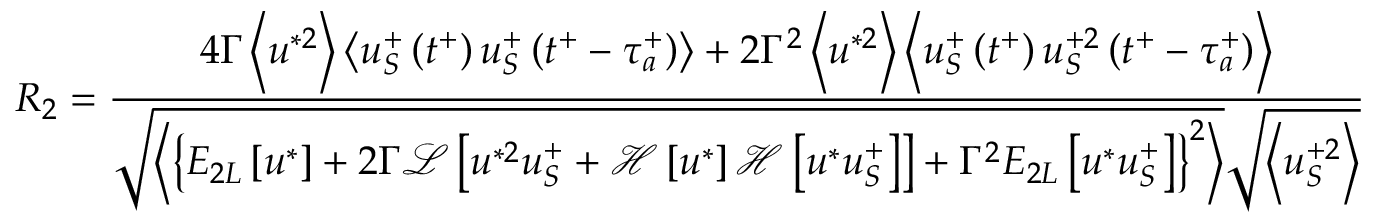Convert formula to latex. <formula><loc_0><loc_0><loc_500><loc_500>R _ { 2 } = \frac { 4 \Gamma \left < u ^ { * 2 } \right > \left < u _ { S } ^ { + } \left ( t ^ { + } \right ) u _ { S } ^ { + } \left ( t ^ { + } - \tau _ { a } ^ { + } \right ) \right > + 2 \Gamma ^ { 2 } \left < u ^ { * 2 } \right > \left < u _ { S } ^ { + } \left ( t ^ { + } \right ) u _ { S } ^ { + 2 } \left ( t ^ { + } - \tau _ { a } ^ { + } \right ) \right > } { \sqrt { \left < \left \{ E _ { 2 L } \left [ u ^ { * } \right ] + 2 \Gamma \mathcal { L } \left [ u ^ { * 2 } u _ { S } ^ { + } + \mathcal { H } \left [ u ^ { * } \right ] \mathcal { H } \left [ u ^ { * } u _ { S } ^ { + } \right ] \right ] + \Gamma ^ { 2 } E _ { 2 L } \left [ u ^ { * } u _ { S } ^ { + } \right ] \right \} ^ { 2 } \right > } \sqrt { \left < u _ { S } ^ { + 2 } \right > } }</formula> 